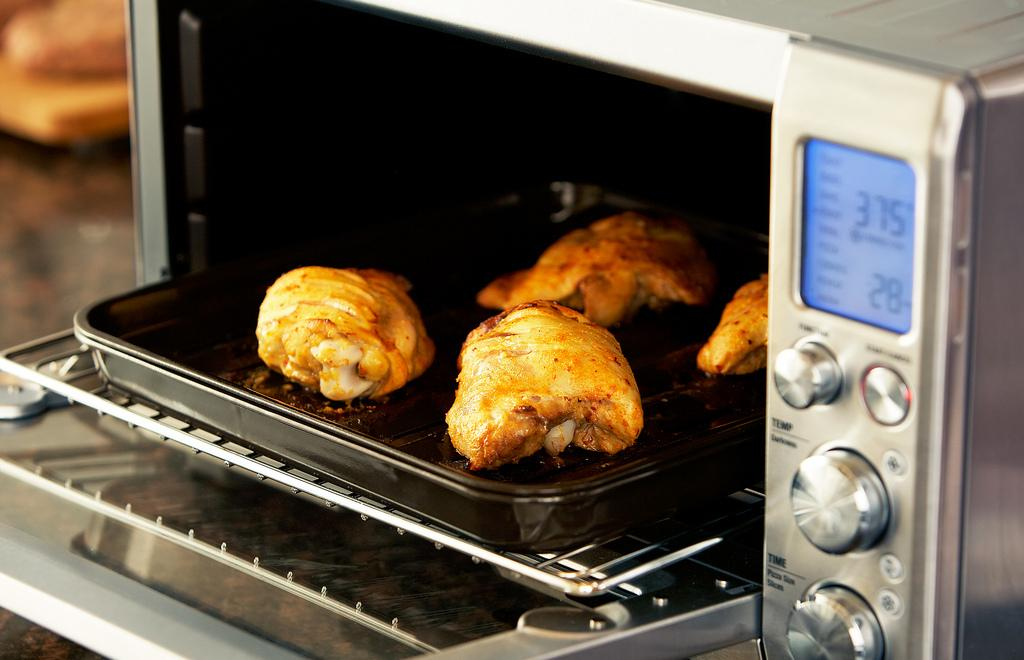<image>
Give a short and clear explanation of the subsequent image. toaster oven is set at 375 and is baking chicken 